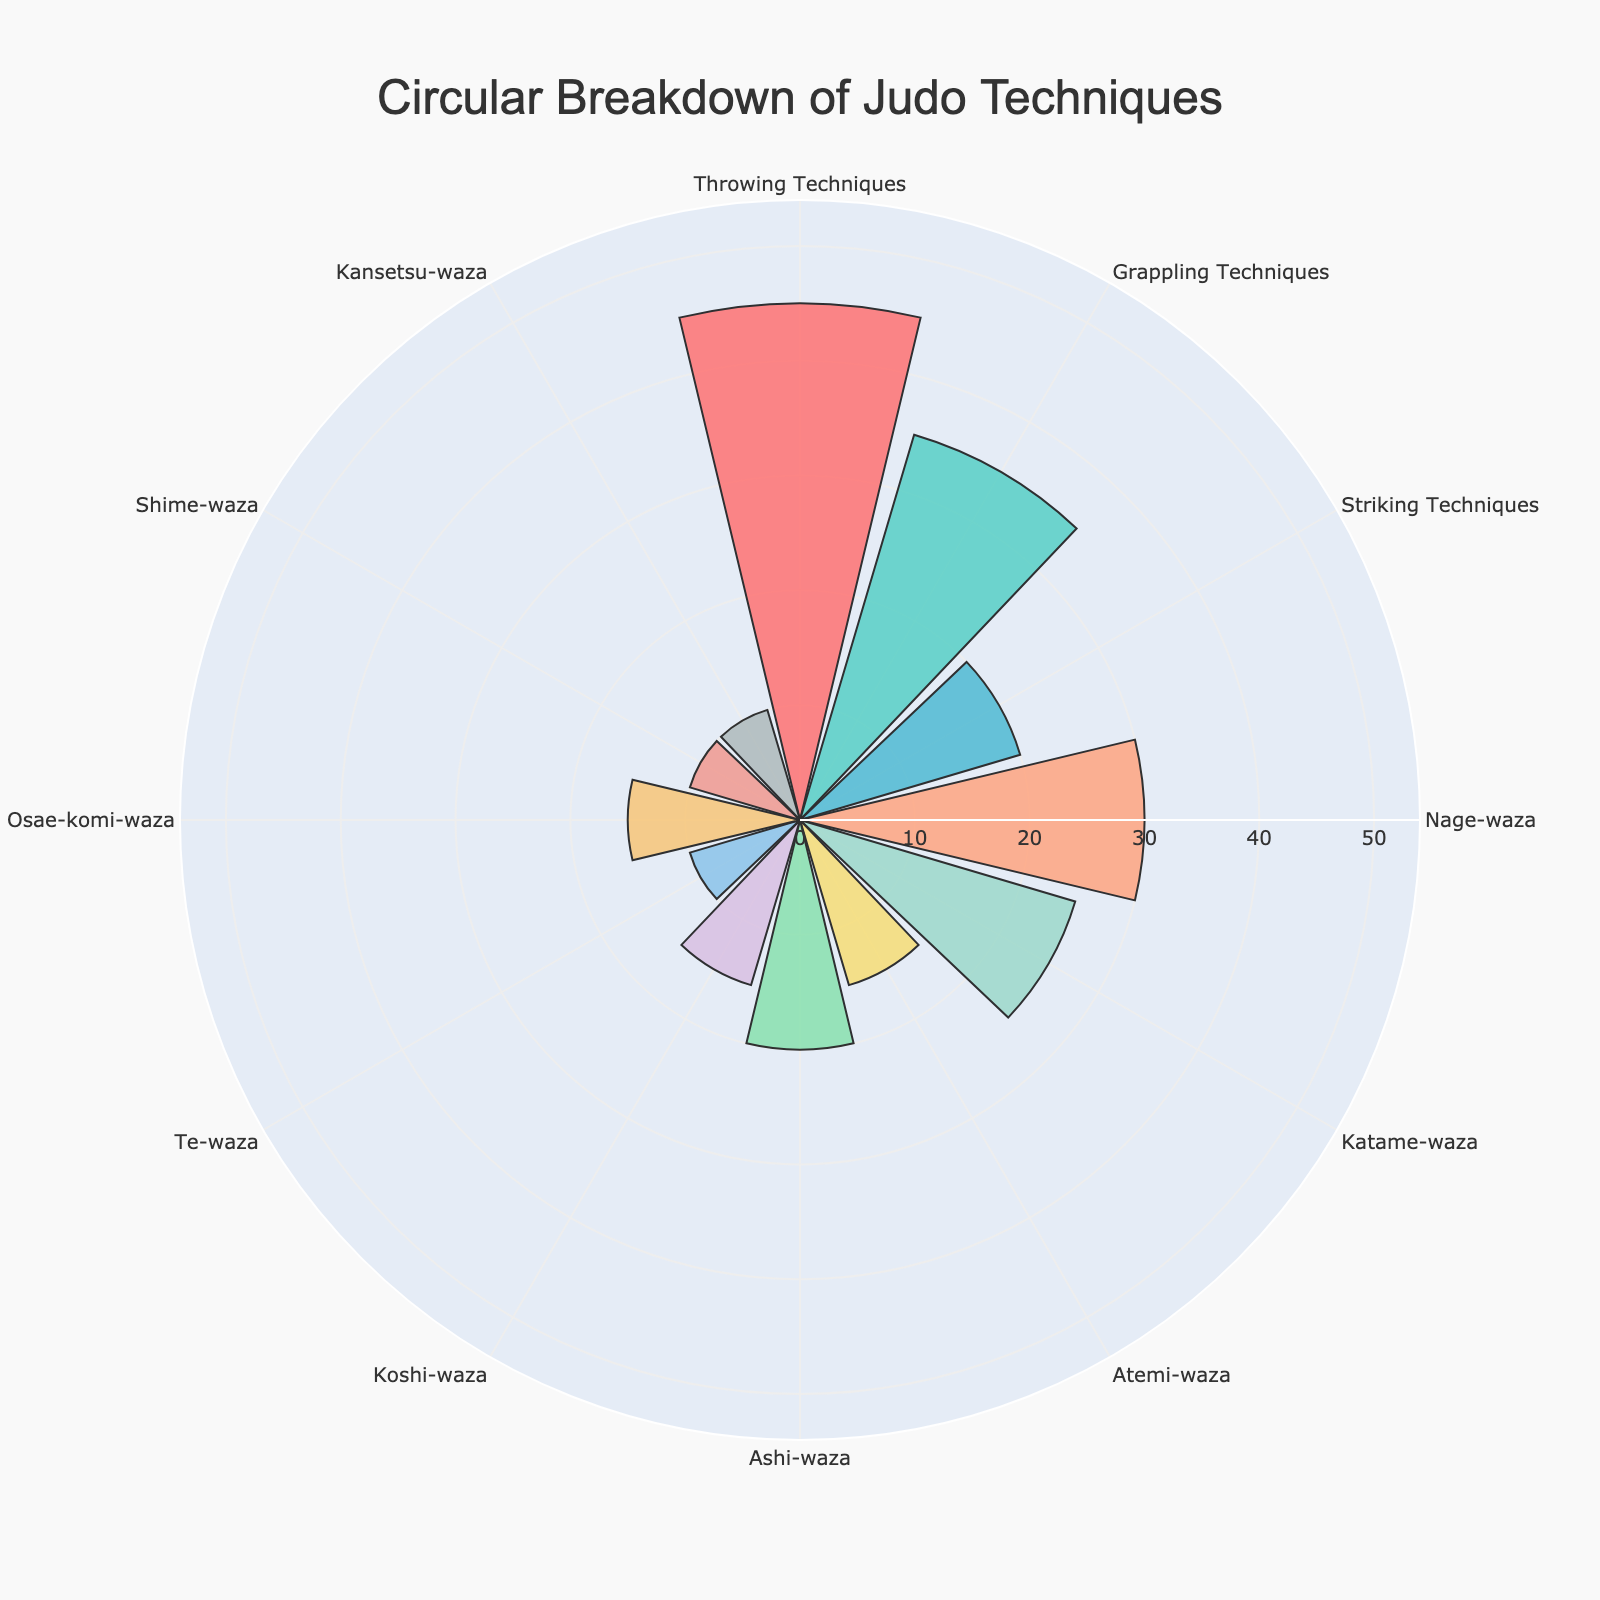What technique category has the highest percentage? By inspecting the figure, observe which category reaches the furthest outwards on the radial axis. This will indicate the highest percentage.
Answer: Throwing Techniques What is the percentage of Striking Techniques? Locate the segment labeled "Striking Techniques" on the polar chart and read its radial value.
Answer: 20% How many categories have a percentage greater than 20%? Identify all segments with their radial values exceeding 20%. Count these segments.
Answer: 3 What's the total percentage for all grappling-related categories? Sum the percentages of all grappling techniques (Katame-waza: 25, Osae-komi-waza: 15, Shime-waza: 10, Kansetsu-waza: 10).
Answer: 60% Are there more Throwing Techniques or Grappling Techniques? Compare the percentage of "Throwing Techniques" (45%) to "Grappling Techniques" (35%).
Answer: Throwing Techniques Which subcategory of Throwing Techniques has the lowest percentage? Among the subcategories of throwing techniques (Nage-waza, Ashi-waza, Koshi-waza, Te-waza), identify the one with the lowest radial value.
Answer: Te-waza What is the combined percentage of Nage-waza and Koshi-waza? Sum the percentages of Nage-waza (30%) and Koshi-waza (15%).
Answer: 45% How much higher is the percentage of Nage-waza compared to Atemi-waza? Subtract the percentage of Atemi-waza (15%) from Nage-waza (30%).
Answer: 15% What's the median percentage value among the subcategories? Arrange percentages of all subcategories (30, 25, 15, 20, 15, 10, 15, 10, 10) in ascending order and find the middle value.
Answer: 15% Which subcategory has the same percentage as the overall Grappling Techniques category? Compare the overall percentage of Grappling Techniques (35%) to individual subcategories and find the match. None matches directly; double-check subcategories if any logical error was in previous steps.
Answer: None 